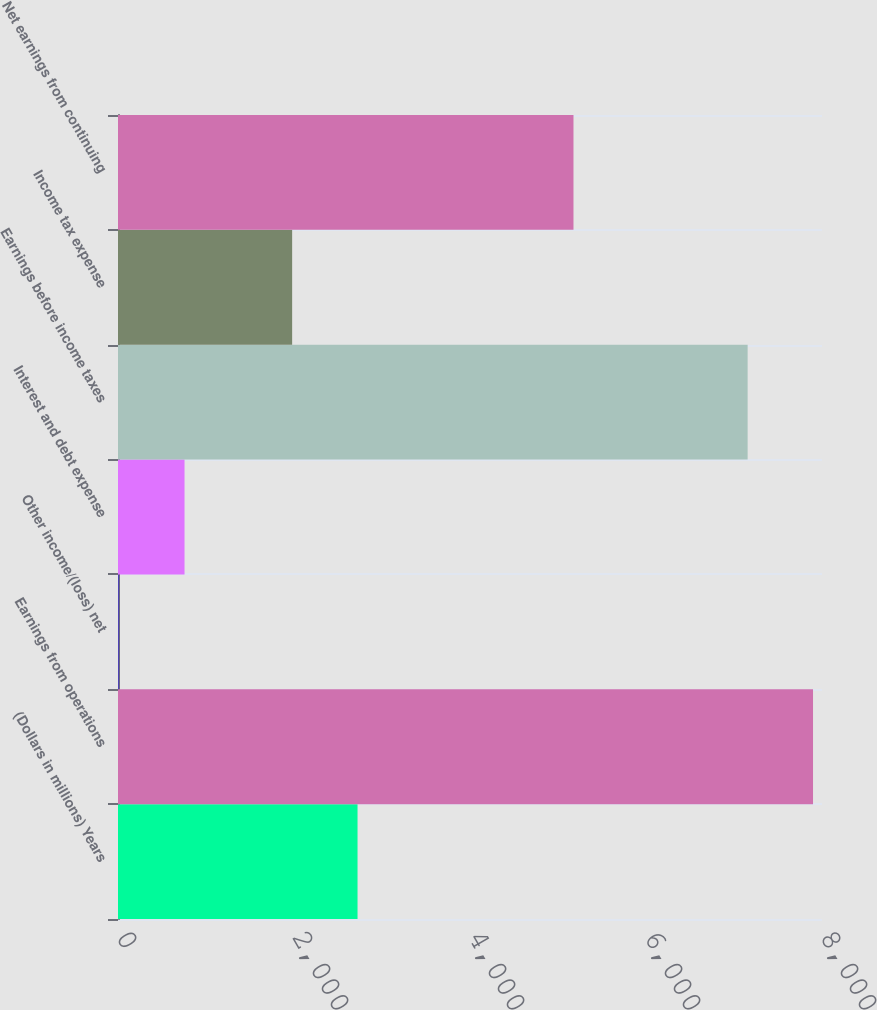Convert chart to OTSL. <chart><loc_0><loc_0><loc_500><loc_500><bar_chart><fcel>(Dollars in millions) Years<fcel>Earnings from operations<fcel>Other income/(loss) net<fcel>Interest and debt expense<fcel>Earnings before income taxes<fcel>Income tax expense<fcel>Net earnings from continuing<nl><fcel>2722<fcel>7898<fcel>13<fcel>756<fcel>7155<fcel>1979<fcel>5176<nl></chart> 